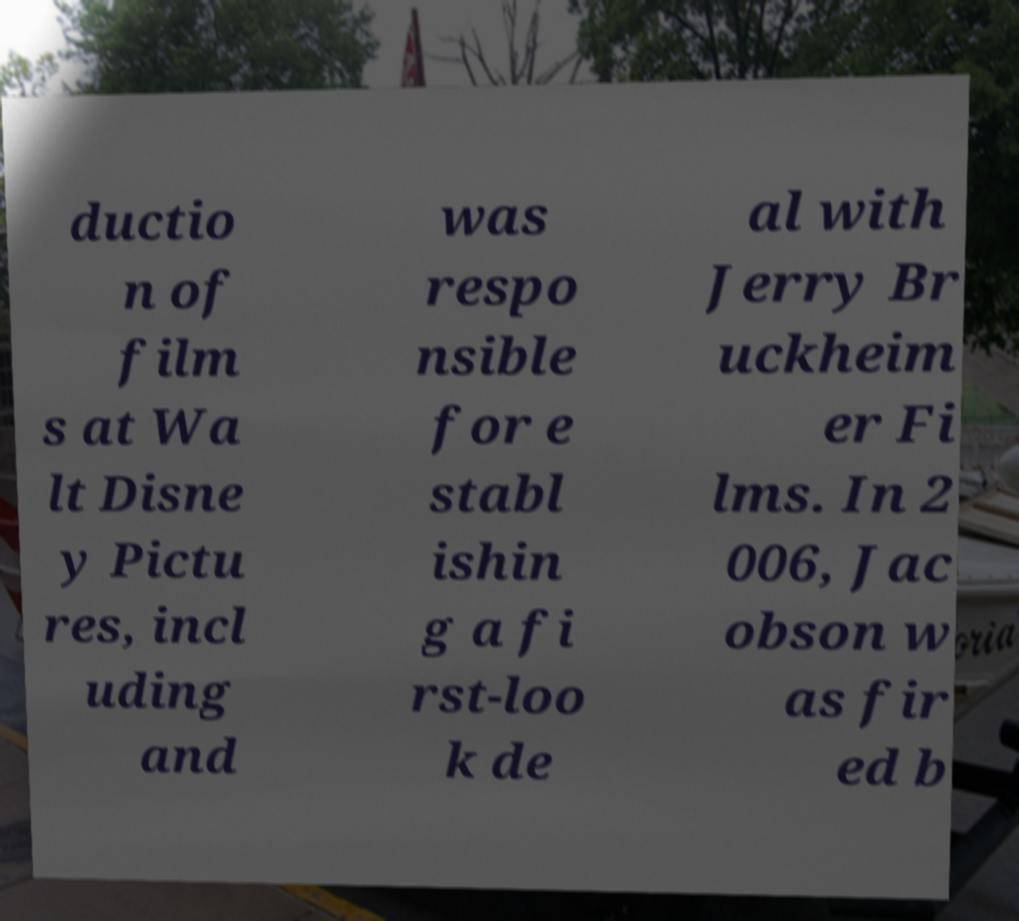For documentation purposes, I need the text within this image transcribed. Could you provide that? ductio n of film s at Wa lt Disne y Pictu res, incl uding and was respo nsible for e stabl ishin g a fi rst-loo k de al with Jerry Br uckheim er Fi lms. In 2 006, Jac obson w as fir ed b 